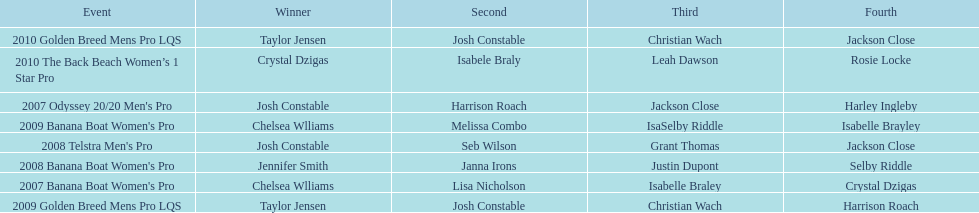How many times was josh constable the winner after 2007? 1. 